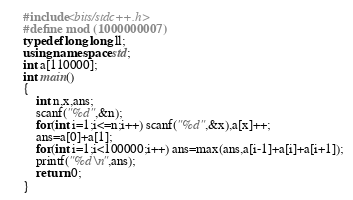Convert code to text. <code><loc_0><loc_0><loc_500><loc_500><_C++_>    #include<bits/stdc++.h>
    #define mod (1000000007)
    typedef long long ll;
    using namespace std;
    int a[110000];
    int main()
    {
    	int n,x,ans;
    	scanf("%d",&n);
    	for(int i=1;i<=n;i++) scanf("%d",&x),a[x]++;
    	ans=a[0]+a[1];
    	for(int i=1;i<100000;i++) ans=max(ans,a[i-1]+a[i]+a[i+1]);
    	printf("%d\n",ans);
    	return 0;
    }</code> 